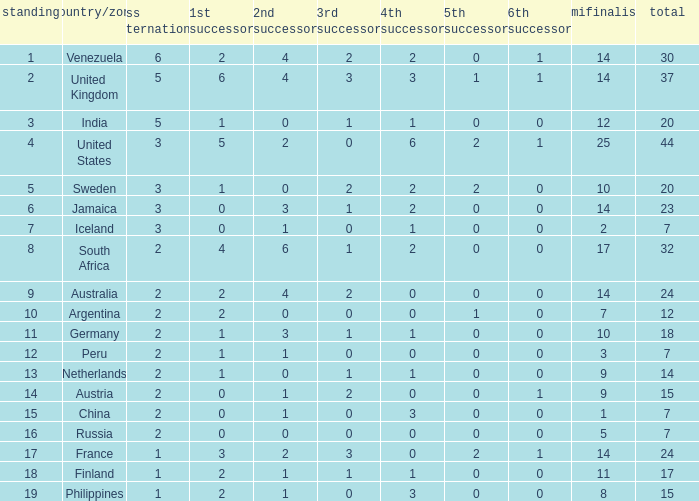Which countries have a 5th runner-up ranking is 2 and the 3rd runner-up ranking is 0 44.0. 